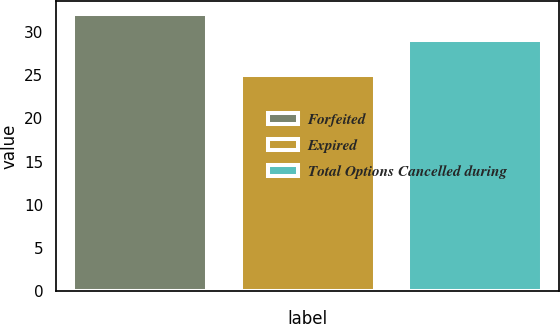Convert chart to OTSL. <chart><loc_0><loc_0><loc_500><loc_500><bar_chart><fcel>Forfeited<fcel>Expired<fcel>Total Options Cancelled during<nl><fcel>32<fcel>25<fcel>29<nl></chart> 